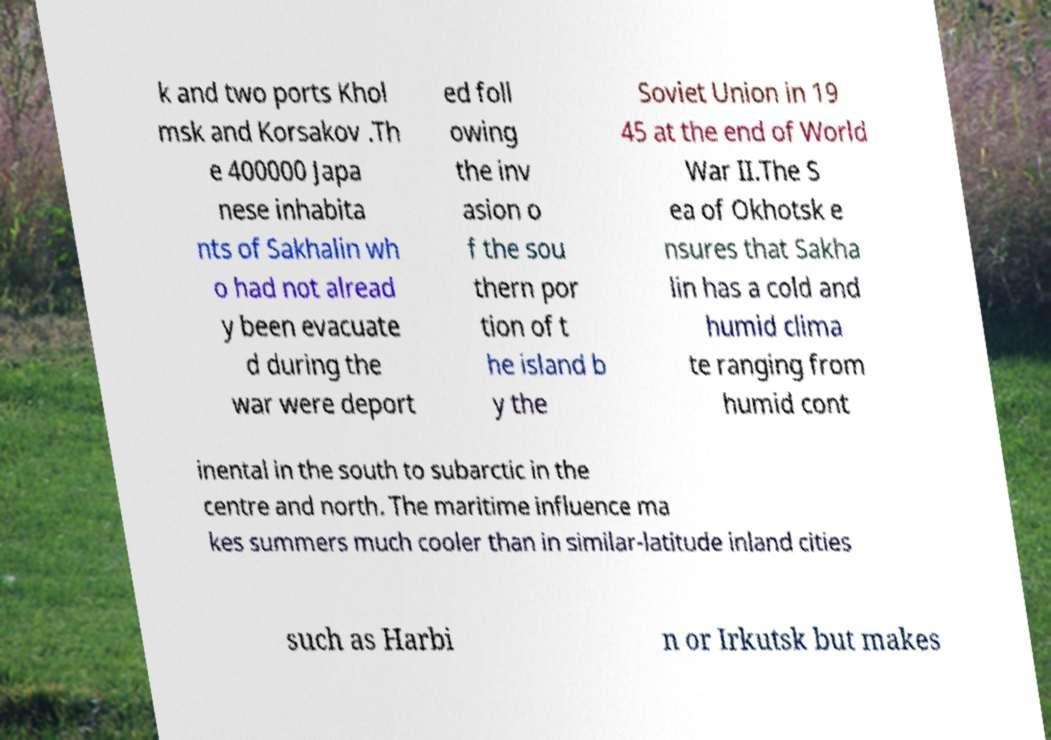What messages or text are displayed in this image? I need them in a readable, typed format. k and two ports Khol msk and Korsakov .Th e 400000 Japa nese inhabita nts of Sakhalin wh o had not alread y been evacuate d during the war were deport ed foll owing the inv asion o f the sou thern por tion of t he island b y the Soviet Union in 19 45 at the end of World War II.The S ea of Okhotsk e nsures that Sakha lin has a cold and humid clima te ranging from humid cont inental in the south to subarctic in the centre and north. The maritime influence ma kes summers much cooler than in similar-latitude inland cities such as Harbi n or Irkutsk but makes 